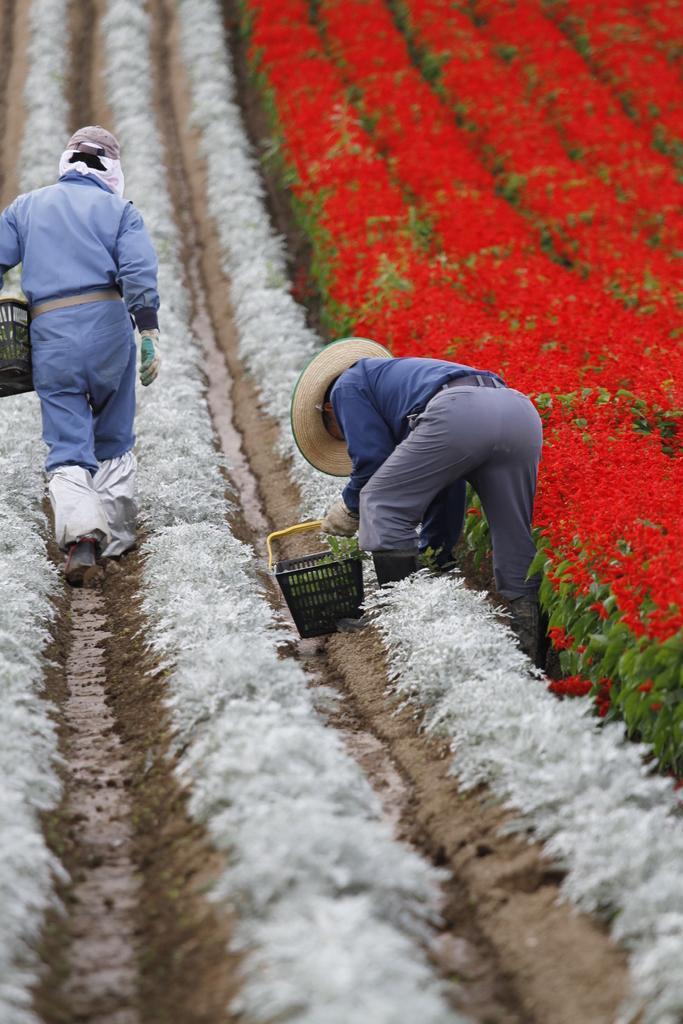In one or two sentences, can you explain what this image depicts? In this image, we can see some plants. There are two persons in the middle of the image wearing clothes and holding baskets with their hands. 